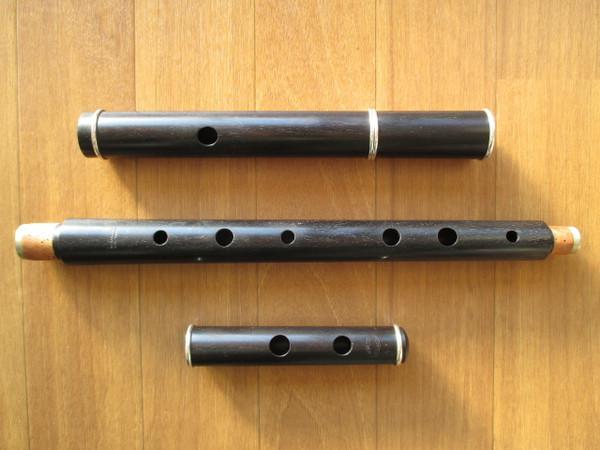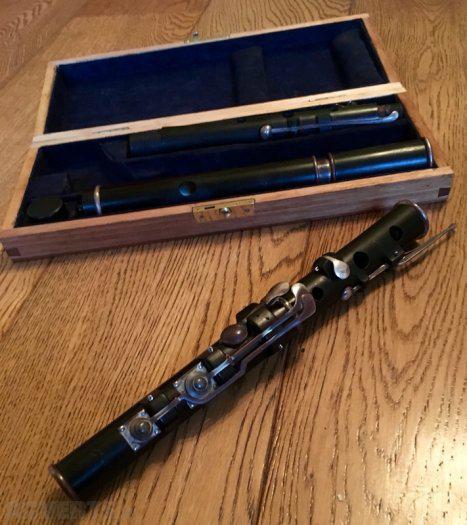The first image is the image on the left, the second image is the image on the right. Analyze the images presented: Is the assertion "The right image features an open case and instrument parts that are not connected, and the left image includes multiple items displayed horizontally but not touching." valid? Answer yes or no. Yes. The first image is the image on the left, the second image is the image on the right. Assess this claim about the two images: "In the image on the right, a brown and black case contains at least 2 sections of a flute.". Correct or not? Answer yes or no. Yes. 